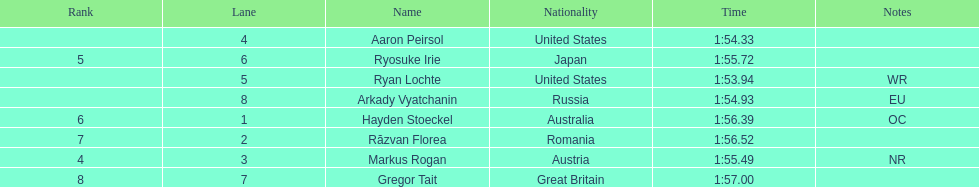How many swimmers finished in less than 1:55? 3. 